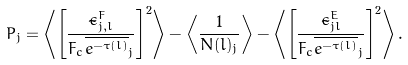<formula> <loc_0><loc_0><loc_500><loc_500>P _ { j } = \left \langle \left [ \frac { \tilde { \epsilon } ^ { F } _ { j , l } } { F _ { c } \overline { e ^ { - \tau ( l ) } } _ { j } } \right ] ^ { 2 } \right \rangle - \left \langle \frac { 1 } { N ( l ) _ { j } } \right \rangle - \left \langle \left [ \frac { \tilde { \epsilon } ^ { E } _ { j l } } { F _ { c } \overline { e ^ { - \tau ( l ) } } _ { j } } \right ] ^ { 2 } \right \rangle .</formula> 